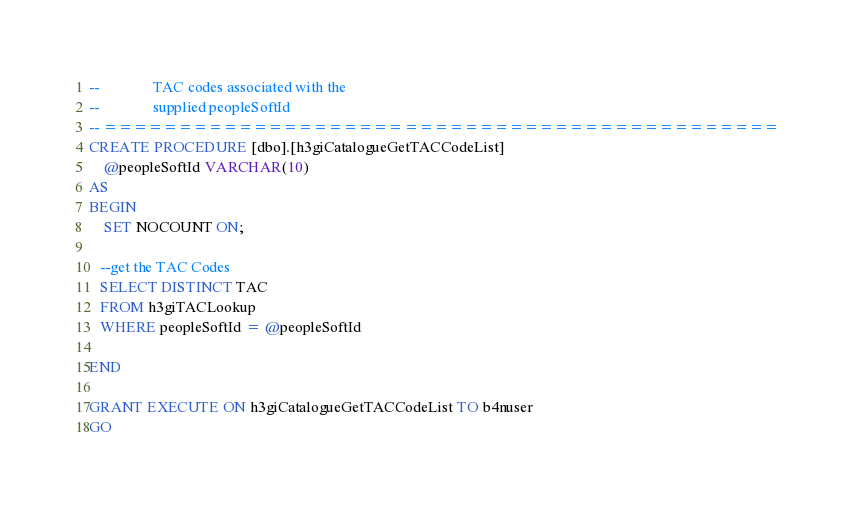<code> <loc_0><loc_0><loc_500><loc_500><_SQL_>--				TAC codes associated with the
--				supplied peopleSoftId
-- =============================================
CREATE PROCEDURE [dbo].[h3giCatalogueGetTACCodeList] 
	@peopleSoftId VARCHAR(10)
AS
BEGIN
	SET NOCOUNT ON;
  
   --get the TAC Codes
   SELECT DISTINCT TAC
   FROM h3giTACLookup
   WHERE peopleSoftId = @peopleSoftId
   
END

GRANT EXECUTE ON h3giCatalogueGetTACCodeList TO b4nuser
GO
</code> 